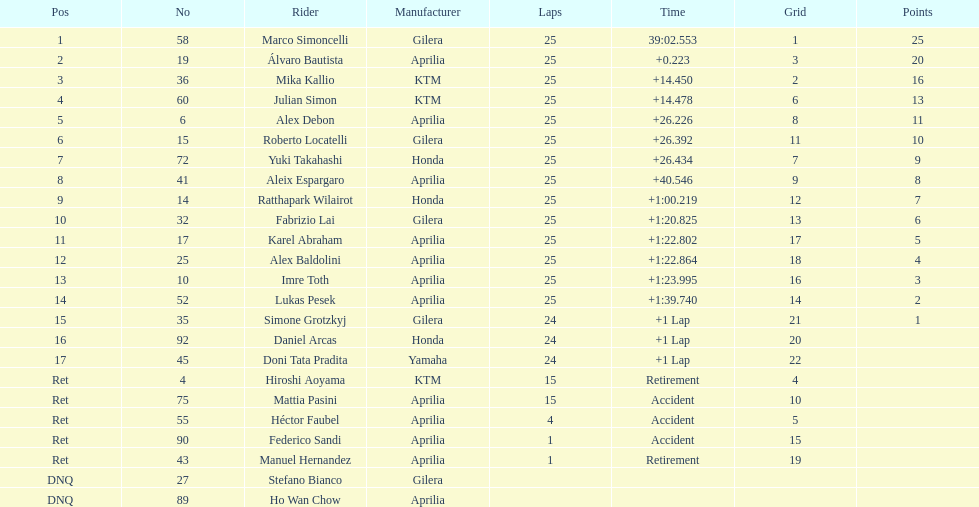How many laps in total has imre toth executed? 25. Give me the full table as a dictionary. {'header': ['Pos', 'No', 'Rider', 'Manufacturer', 'Laps', 'Time', 'Grid', 'Points'], 'rows': [['1', '58', 'Marco Simoncelli', 'Gilera', '25', '39:02.553', '1', '25'], ['2', '19', 'Álvaro Bautista', 'Aprilia', '25', '+0.223', '3', '20'], ['3', '36', 'Mika Kallio', 'KTM', '25', '+14.450', '2', '16'], ['4', '60', 'Julian Simon', 'KTM', '25', '+14.478', '6', '13'], ['5', '6', 'Alex Debon', 'Aprilia', '25', '+26.226', '8', '11'], ['6', '15', 'Roberto Locatelli', 'Gilera', '25', '+26.392', '11', '10'], ['7', '72', 'Yuki Takahashi', 'Honda', '25', '+26.434', '7', '9'], ['8', '41', 'Aleix Espargaro', 'Aprilia', '25', '+40.546', '9', '8'], ['9', '14', 'Ratthapark Wilairot', 'Honda', '25', '+1:00.219', '12', '7'], ['10', '32', 'Fabrizio Lai', 'Gilera', '25', '+1:20.825', '13', '6'], ['11', '17', 'Karel Abraham', 'Aprilia', '25', '+1:22.802', '17', '5'], ['12', '25', 'Alex Baldolini', 'Aprilia', '25', '+1:22.864', '18', '4'], ['13', '10', 'Imre Toth', 'Aprilia', '25', '+1:23.995', '16', '3'], ['14', '52', 'Lukas Pesek', 'Aprilia', '25', '+1:39.740', '14', '2'], ['15', '35', 'Simone Grotzkyj', 'Gilera', '24', '+1 Lap', '21', '1'], ['16', '92', 'Daniel Arcas', 'Honda', '24', '+1 Lap', '20', ''], ['17', '45', 'Doni Tata Pradita', 'Yamaha', '24', '+1 Lap', '22', ''], ['Ret', '4', 'Hiroshi Aoyama', 'KTM', '15', 'Retirement', '4', ''], ['Ret', '75', 'Mattia Pasini', 'Aprilia', '15', 'Accident', '10', ''], ['Ret', '55', 'Héctor Faubel', 'Aprilia', '4', 'Accident', '5', ''], ['Ret', '90', 'Federico Sandi', 'Aprilia', '1', 'Accident', '15', ''], ['Ret', '43', 'Manuel Hernandez', 'Aprilia', '1', 'Retirement', '19', ''], ['DNQ', '27', 'Stefano Bianco', 'Gilera', '', '', '', ''], ['DNQ', '89', 'Ho Wan Chow', 'Aprilia', '', '', '', '']]} 